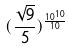<formula> <loc_0><loc_0><loc_500><loc_500>( \frac { \sqrt { 9 } } { 5 } ) ^ { \frac { 1 0 ^ { 1 0 } } { 1 0 } }</formula> 